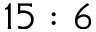Convert formula to latex. <formula><loc_0><loc_0><loc_500><loc_500>1 5 \colon 6</formula> 